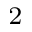Convert formula to latex. <formula><loc_0><loc_0><loc_500><loc_500>_ { 2 }</formula> 